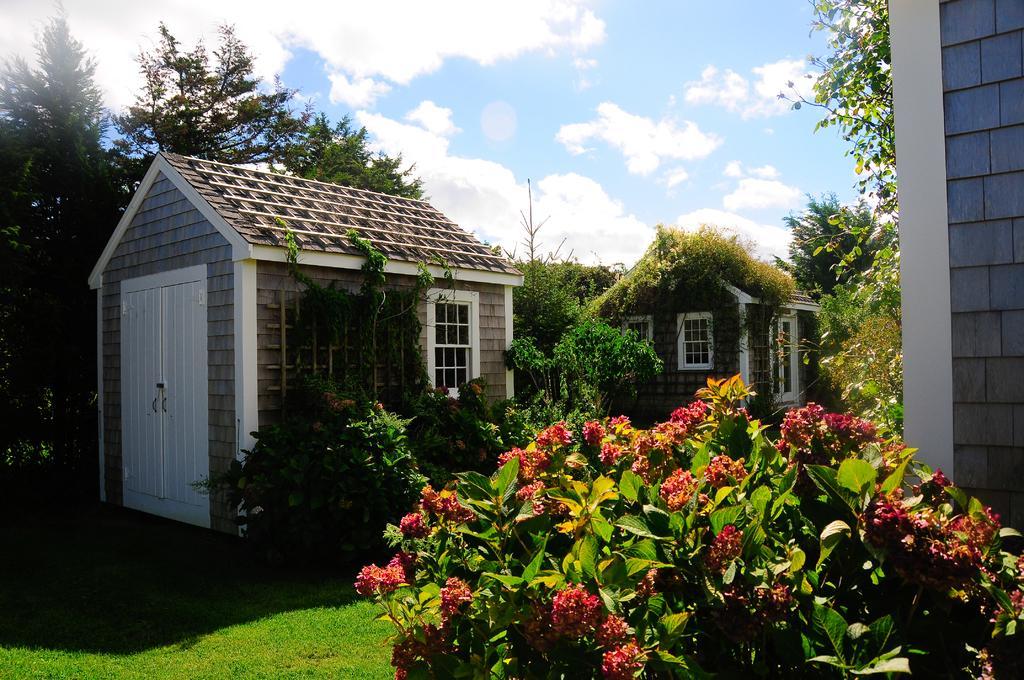How would you summarize this image in a sentence or two? In the image we can see the houses and the windows. Here we can see grass, plants, trees and the cloudy sky. 